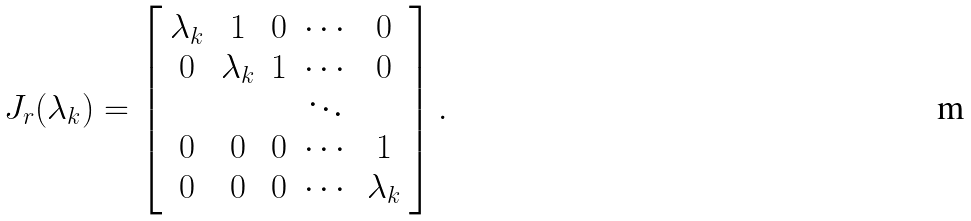Convert formula to latex. <formula><loc_0><loc_0><loc_500><loc_500>J _ { r } ( \lambda _ { k } ) = \left [ \begin{array} { c c c c c } \lambda _ { k } & 1 & 0 & \cdots & 0 \\ 0 & \lambda _ { k } & 1 & \cdots & 0 \\ & & & \ddots & \\ 0 & 0 & 0 & \cdots & 1 \\ 0 & 0 & 0 & \cdots & \lambda _ { k } \end{array} \right ] .</formula> 